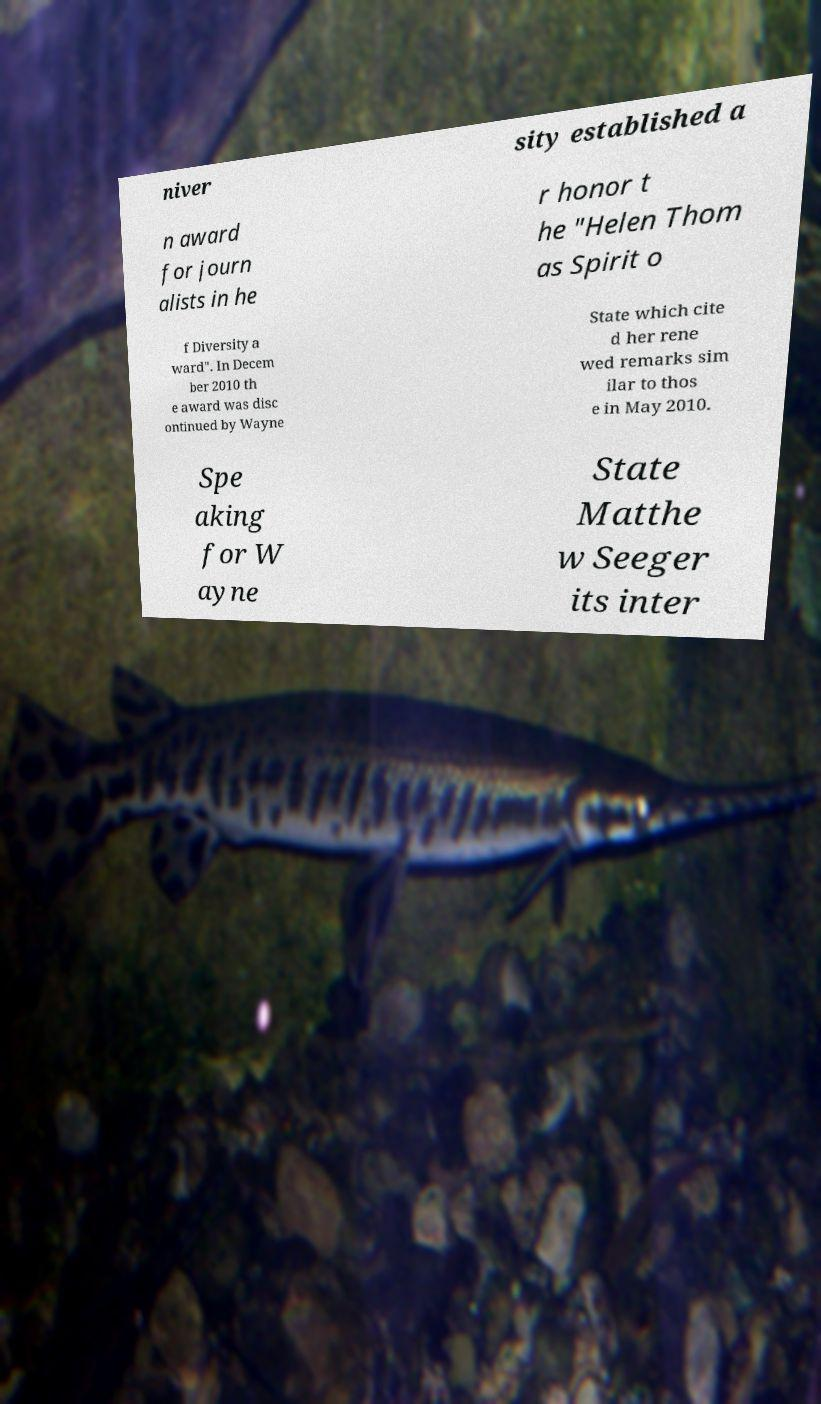There's text embedded in this image that I need extracted. Can you transcribe it verbatim? niver sity established a n award for journ alists in he r honor t he "Helen Thom as Spirit o f Diversity a ward". In Decem ber 2010 th e award was disc ontinued by Wayne State which cite d her rene wed remarks sim ilar to thos e in May 2010. Spe aking for W ayne State Matthe w Seeger its inter 